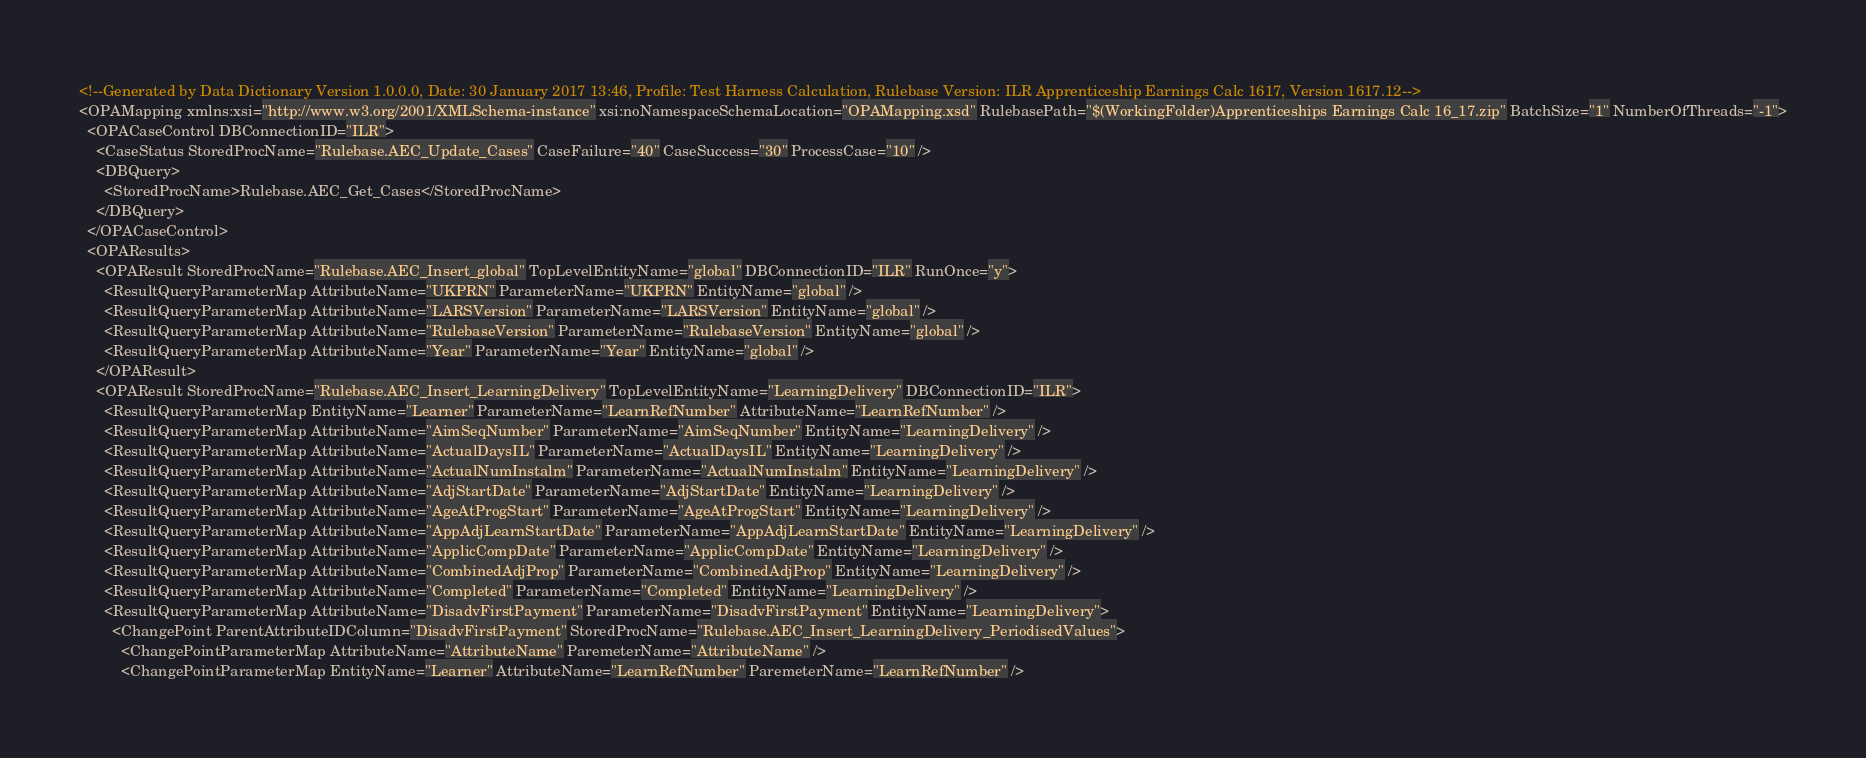Convert code to text. <code><loc_0><loc_0><loc_500><loc_500><_XML_><!--Generated by Data Dictionary Version 1.0.0.0, Date: 30 January 2017 13:46, Profile: Test Harness Calculation, Rulebase Version: ILR Apprenticeship Earnings Calc 1617, Version 1617.12-->
<OPAMapping xmlns:xsi="http://www.w3.org/2001/XMLSchema-instance" xsi:noNamespaceSchemaLocation="OPAMapping.xsd" RulebasePath="$(WorkingFolder)Apprenticeships Earnings Calc 16_17.zip" BatchSize="1" NumberOfThreads="-1">
  <OPACaseControl DBConnectionID="ILR">
    <CaseStatus StoredProcName="Rulebase.AEC_Update_Cases" CaseFailure="40" CaseSuccess="30" ProcessCase="10" />
    <DBQuery>
      <StoredProcName>Rulebase.AEC_Get_Cases</StoredProcName>
    </DBQuery>
  </OPACaseControl>
  <OPAResults>
    <OPAResult StoredProcName="Rulebase.AEC_Insert_global" TopLevelEntityName="global" DBConnectionID="ILR" RunOnce="y">
      <ResultQueryParameterMap AttributeName="UKPRN" ParameterName="UKPRN" EntityName="global" />
      <ResultQueryParameterMap AttributeName="LARSVersion" ParameterName="LARSVersion" EntityName="global" />
      <ResultQueryParameterMap AttributeName="RulebaseVersion" ParameterName="RulebaseVersion" EntityName="global" />
      <ResultQueryParameterMap AttributeName="Year" ParameterName="Year" EntityName="global" />
    </OPAResult>
    <OPAResult StoredProcName="Rulebase.AEC_Insert_LearningDelivery" TopLevelEntityName="LearningDelivery" DBConnectionID="ILR">
      <ResultQueryParameterMap EntityName="Learner" ParameterName="LearnRefNumber" AttributeName="LearnRefNumber" />
      <ResultQueryParameterMap AttributeName="AimSeqNumber" ParameterName="AimSeqNumber" EntityName="LearningDelivery" />
      <ResultQueryParameterMap AttributeName="ActualDaysIL" ParameterName="ActualDaysIL" EntityName="LearningDelivery" />
      <ResultQueryParameterMap AttributeName="ActualNumInstalm" ParameterName="ActualNumInstalm" EntityName="LearningDelivery" />
      <ResultQueryParameterMap AttributeName="AdjStartDate" ParameterName="AdjStartDate" EntityName="LearningDelivery" />
      <ResultQueryParameterMap AttributeName="AgeAtProgStart" ParameterName="AgeAtProgStart" EntityName="LearningDelivery" />
      <ResultQueryParameterMap AttributeName="AppAdjLearnStartDate" ParameterName="AppAdjLearnStartDate" EntityName="LearningDelivery" />
      <ResultQueryParameterMap AttributeName="ApplicCompDate" ParameterName="ApplicCompDate" EntityName="LearningDelivery" />
      <ResultQueryParameterMap AttributeName="CombinedAdjProp" ParameterName="CombinedAdjProp" EntityName="LearningDelivery" />
      <ResultQueryParameterMap AttributeName="Completed" ParameterName="Completed" EntityName="LearningDelivery" />
      <ResultQueryParameterMap AttributeName="DisadvFirstPayment" ParameterName="DisadvFirstPayment" EntityName="LearningDelivery">
        <ChangePoint ParentAttributeIDColumn="DisadvFirstPayment" StoredProcName="Rulebase.AEC_Insert_LearningDelivery_PeriodisedValues">
          <ChangePointParameterMap AttributeName="AttributeName" ParemeterName="AttributeName" />
          <ChangePointParameterMap EntityName="Learner" AttributeName="LearnRefNumber" ParemeterName="LearnRefNumber" /></code> 